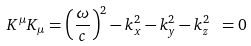Convert formula to latex. <formula><loc_0><loc_0><loc_500><loc_500>K ^ { \mu } K _ { \mu } = \left ( { \frac { \omega } { c } } \right ) ^ { 2 } - k _ { x } ^ { 2 } - k _ { y } ^ { 2 } - k _ { z } ^ { 2 } \ = 0</formula> 